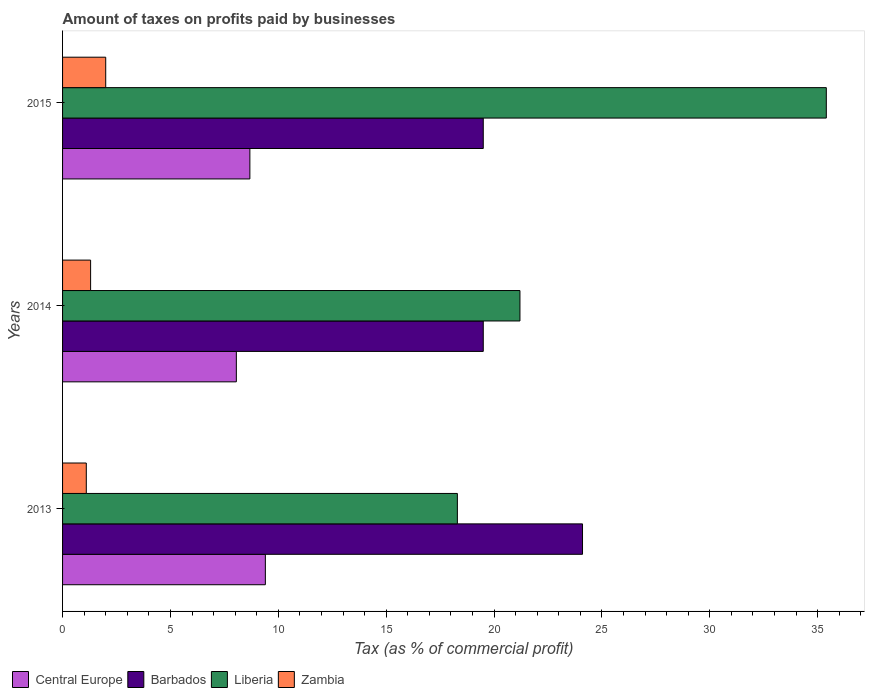How many bars are there on the 2nd tick from the bottom?
Your answer should be very brief. 4. In how many cases, is the number of bars for a given year not equal to the number of legend labels?
Make the answer very short. 0. What is the percentage of taxes paid by businesses in Zambia in 2014?
Your answer should be very brief. 1.3. Across all years, what is the minimum percentage of taxes paid by businesses in Central Europe?
Give a very brief answer. 8.05. In which year was the percentage of taxes paid by businesses in Central Europe minimum?
Ensure brevity in your answer.  2014. What is the total percentage of taxes paid by businesses in Liberia in the graph?
Offer a very short reply. 74.9. What is the difference between the percentage of taxes paid by businesses in Central Europe in 2014 and that in 2015?
Provide a short and direct response. -0.63. What is the average percentage of taxes paid by businesses in Central Europe per year?
Ensure brevity in your answer.  8.71. In the year 2013, what is the difference between the percentage of taxes paid by businesses in Central Europe and percentage of taxes paid by businesses in Barbados?
Offer a terse response. -14.7. In how many years, is the percentage of taxes paid by businesses in Zambia greater than 27 %?
Provide a short and direct response. 0. What is the ratio of the percentage of taxes paid by businesses in Zambia in 2013 to that in 2015?
Offer a terse response. 0.55. Is the difference between the percentage of taxes paid by businesses in Central Europe in 2014 and 2015 greater than the difference between the percentage of taxes paid by businesses in Barbados in 2014 and 2015?
Ensure brevity in your answer.  No. What is the difference between the highest and the second highest percentage of taxes paid by businesses in Liberia?
Your response must be concise. 14.2. What is the difference between the highest and the lowest percentage of taxes paid by businesses in Liberia?
Your answer should be very brief. 17.1. Is the sum of the percentage of taxes paid by businesses in Barbados in 2013 and 2014 greater than the maximum percentage of taxes paid by businesses in Central Europe across all years?
Your response must be concise. Yes. Is it the case that in every year, the sum of the percentage of taxes paid by businesses in Liberia and percentage of taxes paid by businesses in Central Europe is greater than the sum of percentage of taxes paid by businesses in Barbados and percentage of taxes paid by businesses in Zambia?
Provide a succinct answer. No. What does the 4th bar from the top in 2014 represents?
Your answer should be very brief. Central Europe. What does the 2nd bar from the bottom in 2013 represents?
Your answer should be very brief. Barbados. How many bars are there?
Keep it short and to the point. 12. Does the graph contain any zero values?
Your answer should be compact. No. Does the graph contain grids?
Offer a very short reply. No. Where does the legend appear in the graph?
Provide a succinct answer. Bottom left. What is the title of the graph?
Offer a very short reply. Amount of taxes on profits paid by businesses. Does "Cayman Islands" appear as one of the legend labels in the graph?
Offer a terse response. No. What is the label or title of the X-axis?
Give a very brief answer. Tax (as % of commercial profit). What is the label or title of the Y-axis?
Provide a succinct answer. Years. What is the Tax (as % of commercial profit) of Barbados in 2013?
Offer a terse response. 24.1. What is the Tax (as % of commercial profit) of Central Europe in 2014?
Provide a succinct answer. 8.05. What is the Tax (as % of commercial profit) of Liberia in 2014?
Your answer should be compact. 21.2. What is the Tax (as % of commercial profit) of Central Europe in 2015?
Your answer should be compact. 8.68. What is the Tax (as % of commercial profit) in Barbados in 2015?
Your answer should be very brief. 19.5. What is the Tax (as % of commercial profit) in Liberia in 2015?
Provide a succinct answer. 35.4. What is the Tax (as % of commercial profit) of Zambia in 2015?
Your answer should be compact. 2. Across all years, what is the maximum Tax (as % of commercial profit) in Central Europe?
Make the answer very short. 9.4. Across all years, what is the maximum Tax (as % of commercial profit) of Barbados?
Your answer should be very brief. 24.1. Across all years, what is the maximum Tax (as % of commercial profit) in Liberia?
Give a very brief answer. 35.4. Across all years, what is the maximum Tax (as % of commercial profit) in Zambia?
Your response must be concise. 2. Across all years, what is the minimum Tax (as % of commercial profit) of Central Europe?
Offer a very short reply. 8.05. Across all years, what is the minimum Tax (as % of commercial profit) of Barbados?
Ensure brevity in your answer.  19.5. Across all years, what is the minimum Tax (as % of commercial profit) of Liberia?
Keep it short and to the point. 18.3. Across all years, what is the minimum Tax (as % of commercial profit) of Zambia?
Provide a succinct answer. 1.1. What is the total Tax (as % of commercial profit) of Central Europe in the graph?
Your answer should be compact. 26.14. What is the total Tax (as % of commercial profit) in Barbados in the graph?
Ensure brevity in your answer.  63.1. What is the total Tax (as % of commercial profit) in Liberia in the graph?
Make the answer very short. 74.9. What is the total Tax (as % of commercial profit) in Zambia in the graph?
Your answer should be very brief. 4.4. What is the difference between the Tax (as % of commercial profit) of Central Europe in 2013 and that in 2014?
Provide a succinct answer. 1.35. What is the difference between the Tax (as % of commercial profit) of Liberia in 2013 and that in 2014?
Offer a terse response. -2.9. What is the difference between the Tax (as % of commercial profit) of Zambia in 2013 and that in 2014?
Offer a terse response. -0.2. What is the difference between the Tax (as % of commercial profit) of Central Europe in 2013 and that in 2015?
Your response must be concise. 0.72. What is the difference between the Tax (as % of commercial profit) of Liberia in 2013 and that in 2015?
Offer a very short reply. -17.1. What is the difference between the Tax (as % of commercial profit) in Zambia in 2013 and that in 2015?
Offer a terse response. -0.9. What is the difference between the Tax (as % of commercial profit) of Central Europe in 2014 and that in 2015?
Your response must be concise. -0.63. What is the difference between the Tax (as % of commercial profit) in Barbados in 2014 and that in 2015?
Offer a terse response. 0. What is the difference between the Tax (as % of commercial profit) in Liberia in 2014 and that in 2015?
Ensure brevity in your answer.  -14.2. What is the difference between the Tax (as % of commercial profit) in Central Europe in 2013 and the Tax (as % of commercial profit) in Barbados in 2014?
Offer a very short reply. -10.1. What is the difference between the Tax (as % of commercial profit) in Central Europe in 2013 and the Tax (as % of commercial profit) in Zambia in 2014?
Offer a terse response. 8.1. What is the difference between the Tax (as % of commercial profit) in Barbados in 2013 and the Tax (as % of commercial profit) in Liberia in 2014?
Keep it short and to the point. 2.9. What is the difference between the Tax (as % of commercial profit) of Barbados in 2013 and the Tax (as % of commercial profit) of Zambia in 2014?
Ensure brevity in your answer.  22.8. What is the difference between the Tax (as % of commercial profit) of Liberia in 2013 and the Tax (as % of commercial profit) of Zambia in 2014?
Your answer should be compact. 17. What is the difference between the Tax (as % of commercial profit) of Central Europe in 2013 and the Tax (as % of commercial profit) of Zambia in 2015?
Make the answer very short. 7.4. What is the difference between the Tax (as % of commercial profit) of Barbados in 2013 and the Tax (as % of commercial profit) of Zambia in 2015?
Give a very brief answer. 22.1. What is the difference between the Tax (as % of commercial profit) of Liberia in 2013 and the Tax (as % of commercial profit) of Zambia in 2015?
Keep it short and to the point. 16.3. What is the difference between the Tax (as % of commercial profit) in Central Europe in 2014 and the Tax (as % of commercial profit) in Barbados in 2015?
Provide a short and direct response. -11.45. What is the difference between the Tax (as % of commercial profit) of Central Europe in 2014 and the Tax (as % of commercial profit) of Liberia in 2015?
Offer a terse response. -27.35. What is the difference between the Tax (as % of commercial profit) of Central Europe in 2014 and the Tax (as % of commercial profit) of Zambia in 2015?
Your answer should be very brief. 6.05. What is the difference between the Tax (as % of commercial profit) in Barbados in 2014 and the Tax (as % of commercial profit) in Liberia in 2015?
Your response must be concise. -15.9. What is the average Tax (as % of commercial profit) of Central Europe per year?
Make the answer very short. 8.71. What is the average Tax (as % of commercial profit) in Barbados per year?
Provide a short and direct response. 21.03. What is the average Tax (as % of commercial profit) in Liberia per year?
Offer a terse response. 24.97. What is the average Tax (as % of commercial profit) of Zambia per year?
Your answer should be compact. 1.47. In the year 2013, what is the difference between the Tax (as % of commercial profit) of Central Europe and Tax (as % of commercial profit) of Barbados?
Make the answer very short. -14.7. In the year 2013, what is the difference between the Tax (as % of commercial profit) in Barbados and Tax (as % of commercial profit) in Zambia?
Your response must be concise. 23. In the year 2013, what is the difference between the Tax (as % of commercial profit) in Liberia and Tax (as % of commercial profit) in Zambia?
Your answer should be compact. 17.2. In the year 2014, what is the difference between the Tax (as % of commercial profit) in Central Europe and Tax (as % of commercial profit) in Barbados?
Your answer should be compact. -11.45. In the year 2014, what is the difference between the Tax (as % of commercial profit) of Central Europe and Tax (as % of commercial profit) of Liberia?
Ensure brevity in your answer.  -13.15. In the year 2014, what is the difference between the Tax (as % of commercial profit) in Central Europe and Tax (as % of commercial profit) in Zambia?
Make the answer very short. 6.75. In the year 2015, what is the difference between the Tax (as % of commercial profit) of Central Europe and Tax (as % of commercial profit) of Barbados?
Ensure brevity in your answer.  -10.82. In the year 2015, what is the difference between the Tax (as % of commercial profit) of Central Europe and Tax (as % of commercial profit) of Liberia?
Provide a short and direct response. -26.72. In the year 2015, what is the difference between the Tax (as % of commercial profit) in Central Europe and Tax (as % of commercial profit) in Zambia?
Keep it short and to the point. 6.68. In the year 2015, what is the difference between the Tax (as % of commercial profit) in Barbados and Tax (as % of commercial profit) in Liberia?
Offer a terse response. -15.9. In the year 2015, what is the difference between the Tax (as % of commercial profit) in Barbados and Tax (as % of commercial profit) in Zambia?
Provide a short and direct response. 17.5. In the year 2015, what is the difference between the Tax (as % of commercial profit) in Liberia and Tax (as % of commercial profit) in Zambia?
Offer a very short reply. 33.4. What is the ratio of the Tax (as % of commercial profit) in Central Europe in 2013 to that in 2014?
Offer a very short reply. 1.17. What is the ratio of the Tax (as % of commercial profit) of Barbados in 2013 to that in 2014?
Give a very brief answer. 1.24. What is the ratio of the Tax (as % of commercial profit) of Liberia in 2013 to that in 2014?
Keep it short and to the point. 0.86. What is the ratio of the Tax (as % of commercial profit) of Zambia in 2013 to that in 2014?
Your answer should be very brief. 0.85. What is the ratio of the Tax (as % of commercial profit) of Central Europe in 2013 to that in 2015?
Your answer should be compact. 1.08. What is the ratio of the Tax (as % of commercial profit) of Barbados in 2013 to that in 2015?
Your answer should be compact. 1.24. What is the ratio of the Tax (as % of commercial profit) in Liberia in 2013 to that in 2015?
Ensure brevity in your answer.  0.52. What is the ratio of the Tax (as % of commercial profit) in Zambia in 2013 to that in 2015?
Your response must be concise. 0.55. What is the ratio of the Tax (as % of commercial profit) in Central Europe in 2014 to that in 2015?
Make the answer very short. 0.93. What is the ratio of the Tax (as % of commercial profit) of Liberia in 2014 to that in 2015?
Ensure brevity in your answer.  0.6. What is the ratio of the Tax (as % of commercial profit) of Zambia in 2014 to that in 2015?
Keep it short and to the point. 0.65. What is the difference between the highest and the second highest Tax (as % of commercial profit) in Central Europe?
Your response must be concise. 0.72. What is the difference between the highest and the second highest Tax (as % of commercial profit) of Zambia?
Your answer should be compact. 0.7. What is the difference between the highest and the lowest Tax (as % of commercial profit) in Central Europe?
Offer a terse response. 1.35. What is the difference between the highest and the lowest Tax (as % of commercial profit) of Barbados?
Give a very brief answer. 4.6. What is the difference between the highest and the lowest Tax (as % of commercial profit) of Liberia?
Keep it short and to the point. 17.1. 